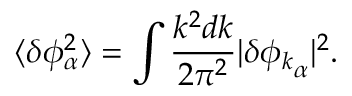Convert formula to latex. <formula><loc_0><loc_0><loc_500><loc_500>\langle \delta \phi _ { \alpha } ^ { 2 } \rangle = \int \frac { k ^ { 2 } d k } { 2 \pi ^ { 2 } } | { \delta \phi _ { k } } _ { \alpha } | ^ { 2 } .</formula> 